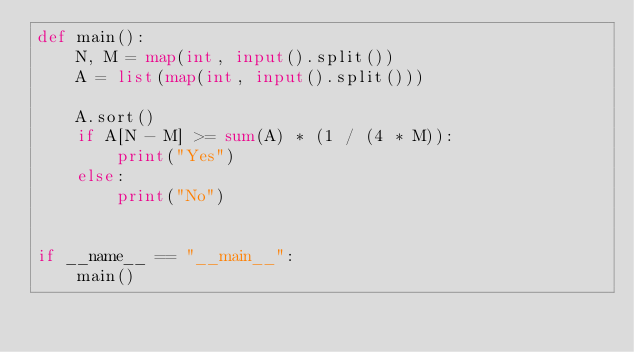Convert code to text. <code><loc_0><loc_0><loc_500><loc_500><_Python_>def main():
    N, M = map(int, input().split())
    A = list(map(int, input().split()))

    A.sort()
    if A[N - M] >= sum(A) * (1 / (4 * M)):
        print("Yes")
    else:
        print("No")


if __name__ == "__main__":
    main()
</code> 